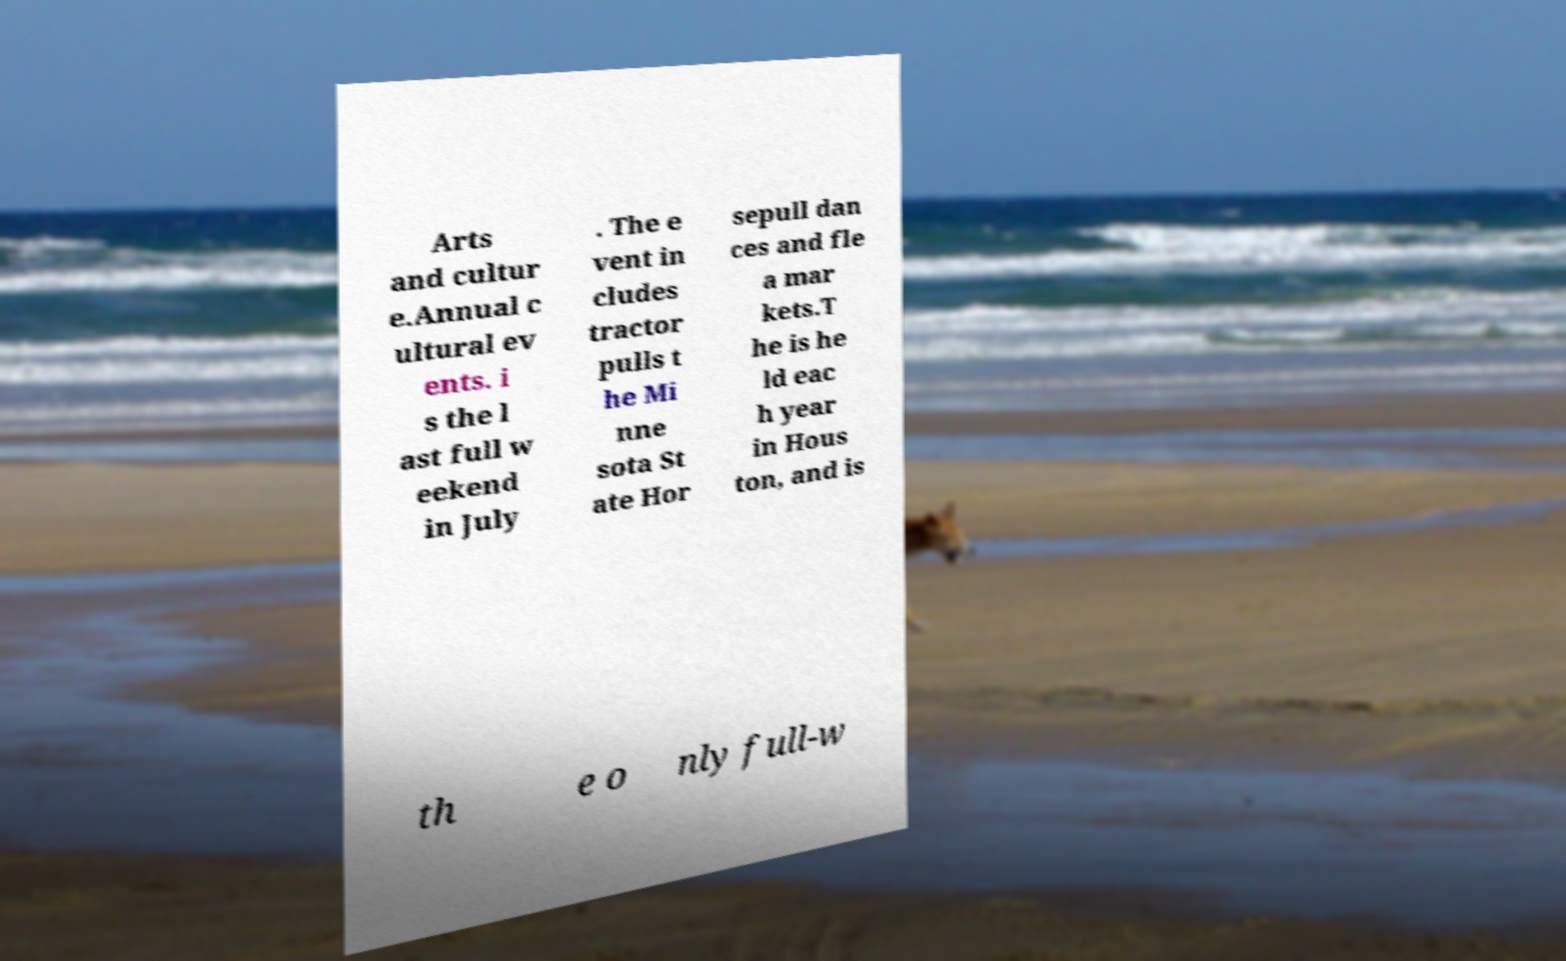Could you assist in decoding the text presented in this image and type it out clearly? Arts and cultur e.Annual c ultural ev ents. i s the l ast full w eekend in July . The e vent in cludes tractor pulls t he Mi nne sota St ate Hor sepull dan ces and fle a mar kets.T he is he ld eac h year in Hous ton, and is th e o nly full-w 